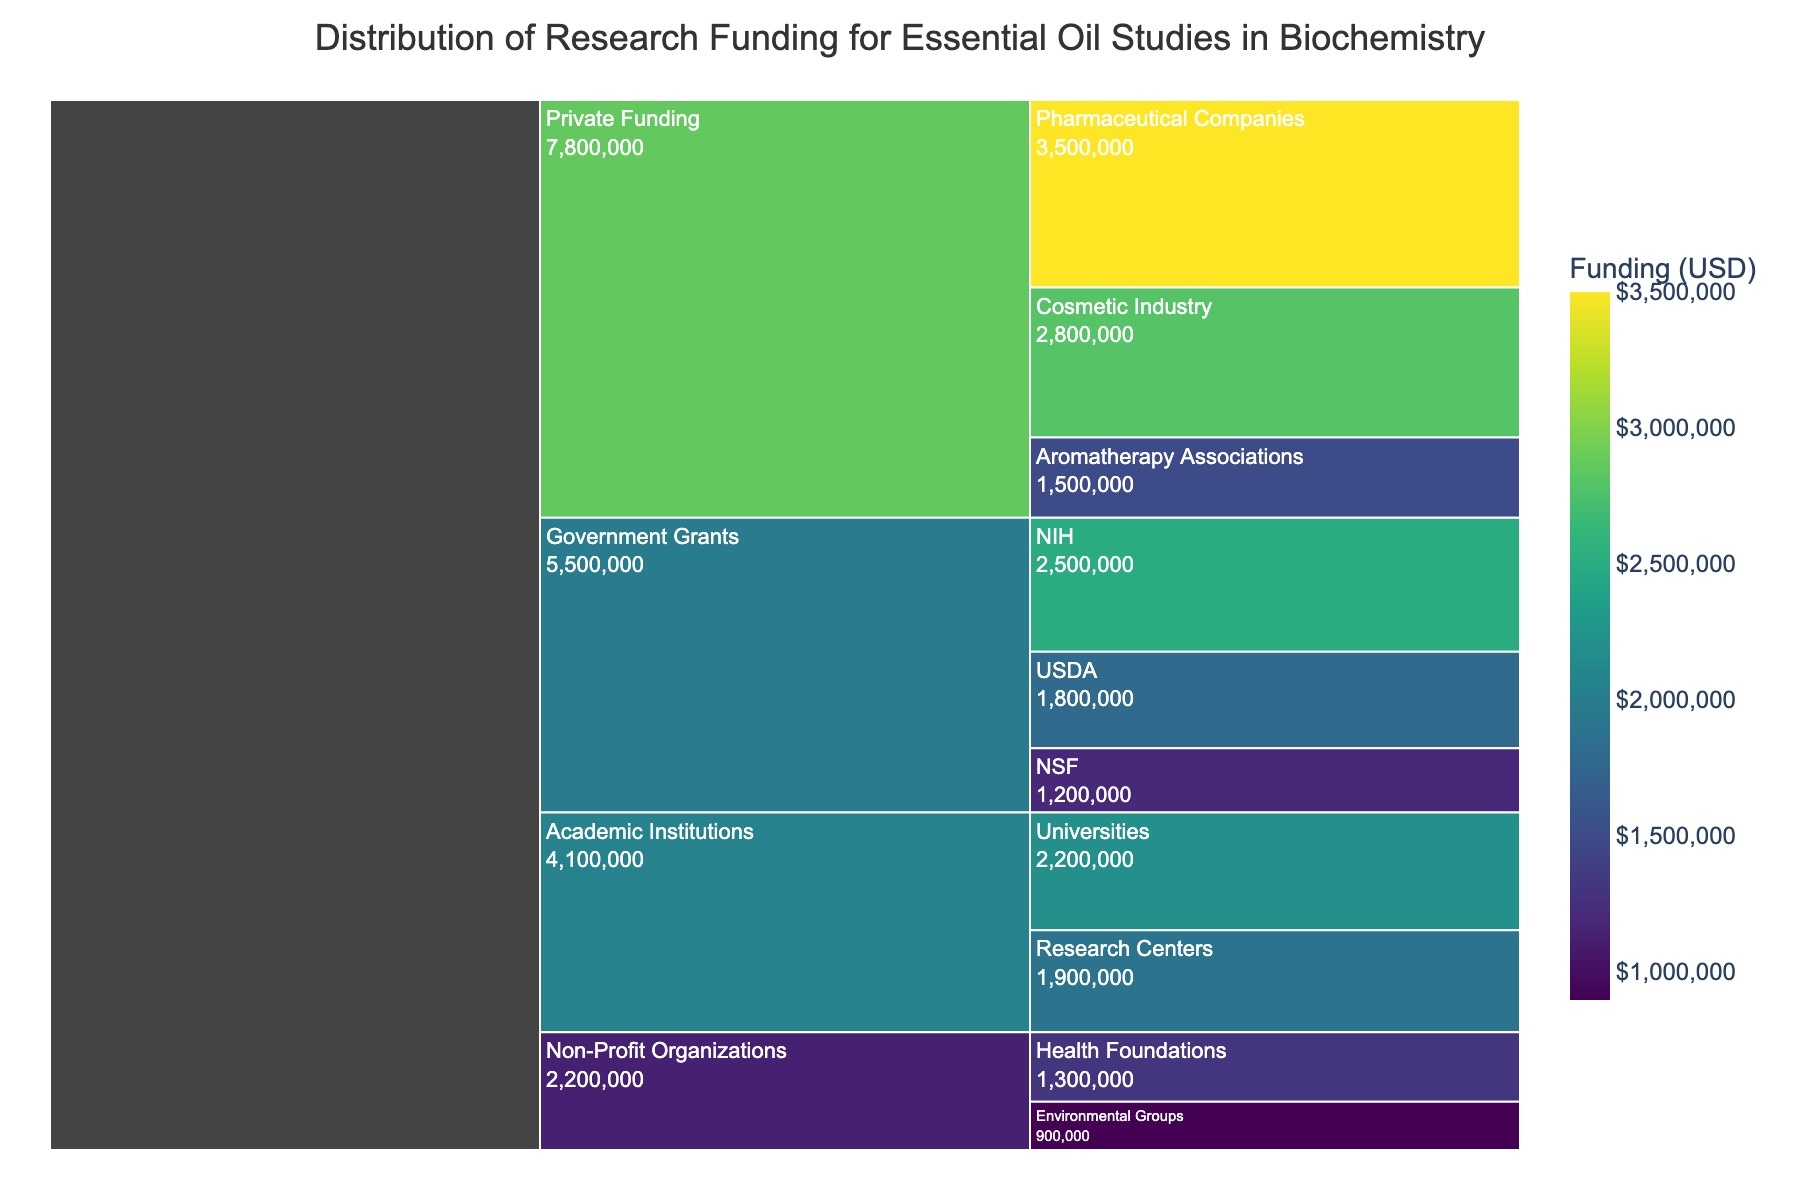1. What is the title of the chart? The title is usually positioned at the top of the chart and provides a brief description of what the chart represents.
Answer: Distribution of Research Funding for Essential Oil Studies in Biochemistry 2. Which funding source has the highest amount of funding? By observing the relative size and funding amount displayed on the icicle chart, the largest section represents the source with the highest funding.
Answer: Pharmaceutical Companies 3. How much funding is provided by the USDA? To find the amount of funding provided by USDA, look for the corresponding section in the Government Grants category.
Answer: $1,800,000 4. What is the total funding provided by Private Funding? Sum the individual funding amounts provided by Pharmaceutical Companies, Cosmetic Industry, and Aromatherapy Associations under the Private Funding category.
Answer: $7,300,000 5. Which subcategory under Academic Institutions receives more funding? Compare the funding amounts of Universities and Research Centers in the Academic Institutions category.
Answer: Universities 6. What is the difference in funding between NIH and NSF? Subtract the funding amount of NSF from the funding amount of NIH to get the difference.
Answer: $1,300,000 7. How many subcategories are under the Non-Profit Organizations category? Count the number of subcategories listed under Non-Profit Organizations.
Answer: 2 8. Is the funding for Research Centers higher than Health Foundations? Compare the funding amounts provided in the chart for Research Centers and Health Foundations.
Answer: Yes 9. Which category provides the lowest total funding? Calculate and compare the total funding across all main categories (Government Grants, Private Funding, Academic Institutions, Non-Profit Organizations).
Answer: Non-Profit Organizations 10. What is the sum of funding from all Government Grants subcategories? Add the funding amounts of NIH, USDA, and NSF to find the total Government Grants funding.
Answer: $5,500,000 